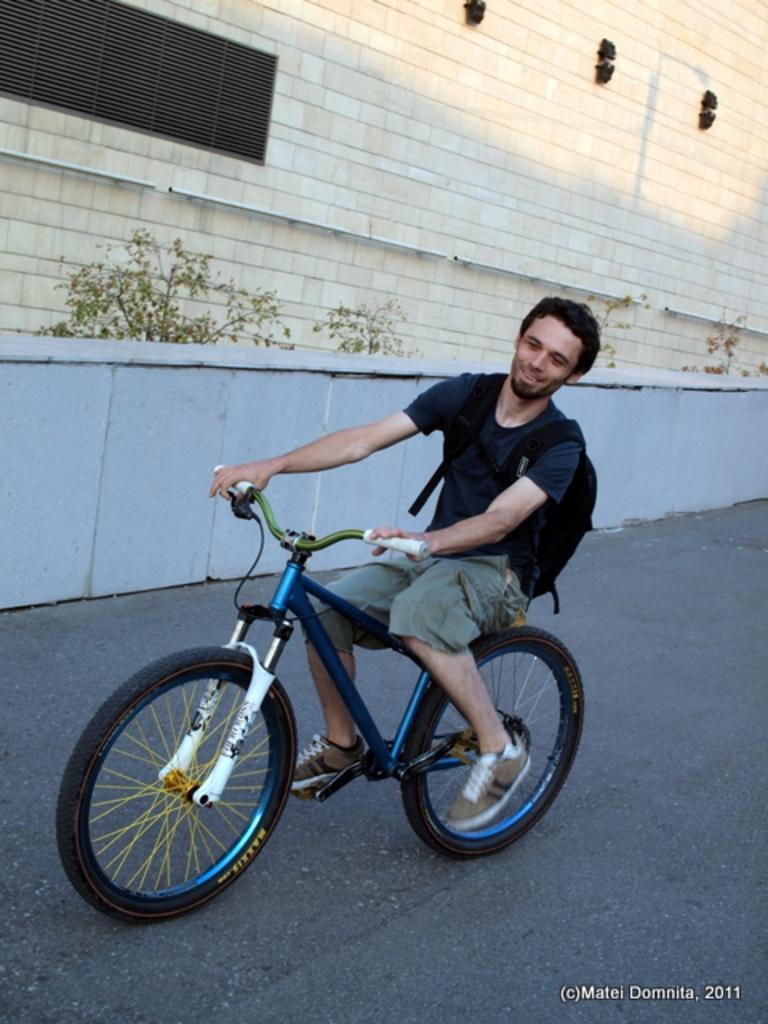What is the man in the image doing? The man is riding a bicycle in the image. What color is the bicycle the man is riding? The bicycle is blue in color. What is the man wearing on his back? The man is wearing a black bag. What can be seen in the background of the image? There is a wall and plants in the background of the image. What date is circled on the calendar in the image? There is no calendar present in the image. What type of blade is being used by the man in the image? The man is not using any blade in the image; he is riding a bicycle. 